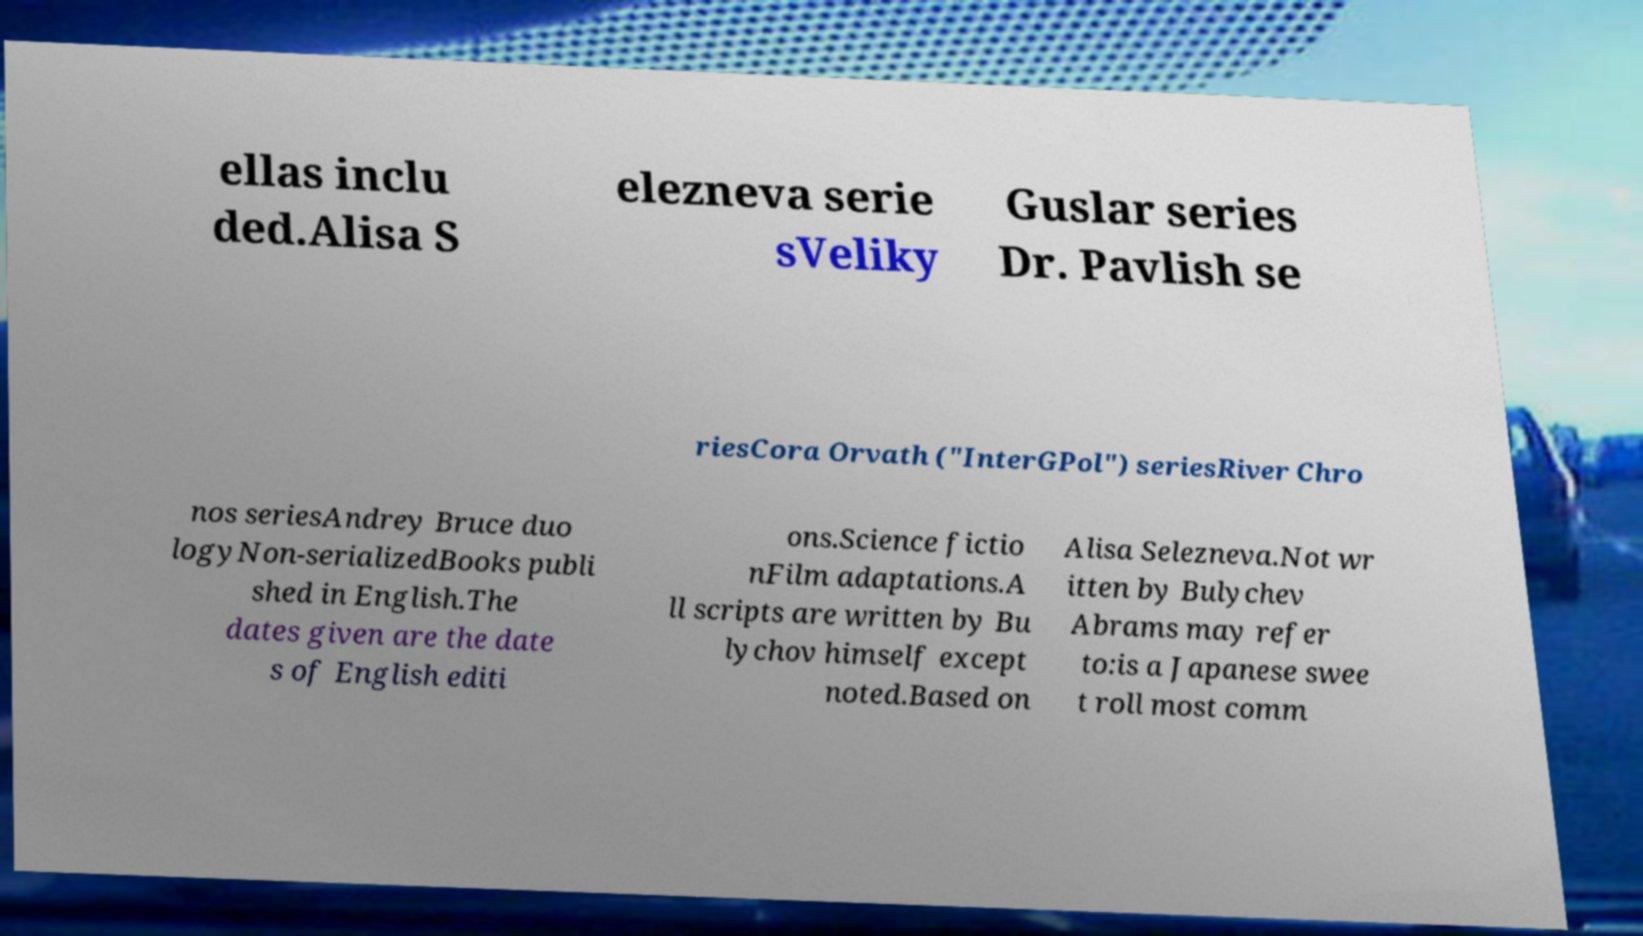Please identify and transcribe the text found in this image. ellas inclu ded.Alisa S elezneva serie sVeliky Guslar series Dr. Pavlish se riesCora Orvath ("InterGPol") seriesRiver Chro nos seriesAndrey Bruce duo logyNon-serializedBooks publi shed in English.The dates given are the date s of English editi ons.Science fictio nFilm adaptations.A ll scripts are written by Bu lychov himself except noted.Based on Alisa Selezneva.Not wr itten by Bulychev Abrams may refer to:is a Japanese swee t roll most comm 